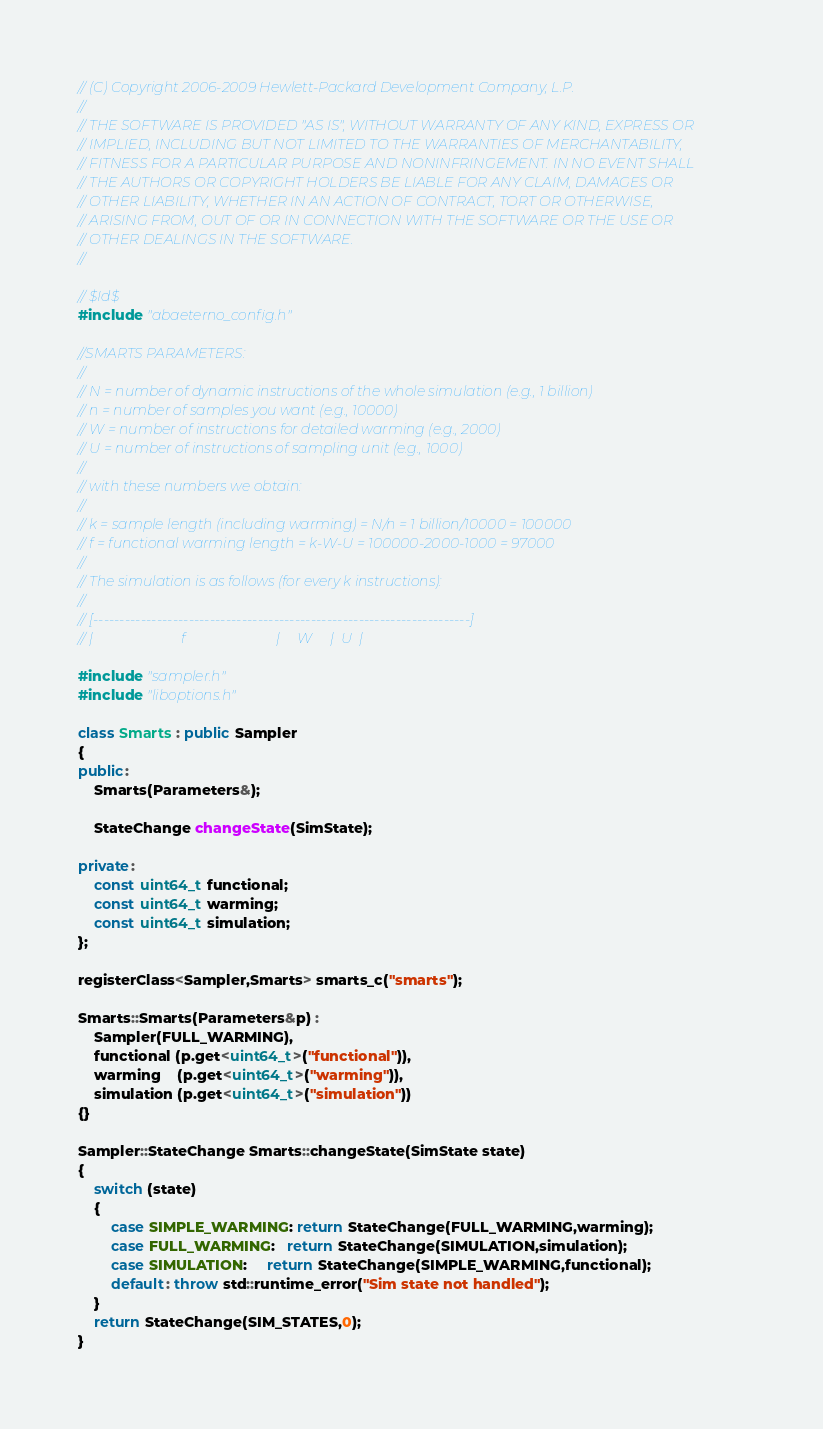Convert code to text. <code><loc_0><loc_0><loc_500><loc_500><_C++_>// (C) Copyright 2006-2009 Hewlett-Packard Development Company, L.P.
//
// THE SOFTWARE IS PROVIDED "AS IS", WITHOUT WARRANTY OF ANY KIND, EXPRESS OR
// IMPLIED, INCLUDING BUT NOT LIMITED TO THE WARRANTIES OF MERCHANTABILITY,
// FITNESS FOR A PARTICULAR PURPOSE AND NONINFRINGEMENT. IN NO EVENT SHALL
// THE AUTHORS OR COPYRIGHT HOLDERS BE LIABLE FOR ANY CLAIM, DAMAGES OR
// OTHER LIABILITY, WHETHER IN AN ACTION OF CONTRACT, TORT OR OTHERWISE,
// ARISING FROM, OUT OF OR IN CONNECTION WITH THE SOFTWARE OR THE USE OR
// OTHER DEALINGS IN THE SOFTWARE.
//

// $Id$
#include "abaeterno_config.h"

//SMARTS PARAMETERS:
//        
// N = number of dynamic instructions of the whole simulation (e.g., 1 billion)
// n = number of samples you want (e.g., 10000)
// W = number of instructions for detailed warming (e.g., 2000)
// U = number of instructions of sampling unit (e.g., 1000)
//        
// with these numbers we obtain:
//        
// k = sample length (including warming) = N/n = 1 billion/10000 = 100000
// f = functional warming length = k-W-U = 100000-2000-1000 = 97000
//                        
// The simulation is as follows (for every k instructions):
//        
// [-----------------------------------------------------------------------]
// |                         f                          |     W     |  U  |

#include "sampler.h"
#include "liboptions.h"

class Smarts : public Sampler
{
public:
	Smarts(Parameters&);

	StateChange changeState(SimState);

private:
	const uint64_t functional;
	const uint64_t warming;
	const uint64_t simulation;
};

registerClass<Sampler,Smarts> smarts_c("smarts");

Smarts::Smarts(Parameters&p) : 
	Sampler(FULL_WARMING),
	functional (p.get<uint64_t>("functional")),
	warming    (p.get<uint64_t>("warming")),
	simulation (p.get<uint64_t>("simulation"))
{}

Sampler::StateChange Smarts::changeState(SimState state)
{
	switch (state) 
	{
		case SIMPLE_WARMING: return StateChange(FULL_WARMING,warming);
		case FULL_WARMING:   return StateChange(SIMULATION,simulation);
		case SIMULATION:     return StateChange(SIMPLE_WARMING,functional);
		default: throw std::runtime_error("Sim state not handled");
	}
	return StateChange(SIM_STATES,0);
}
</code> 